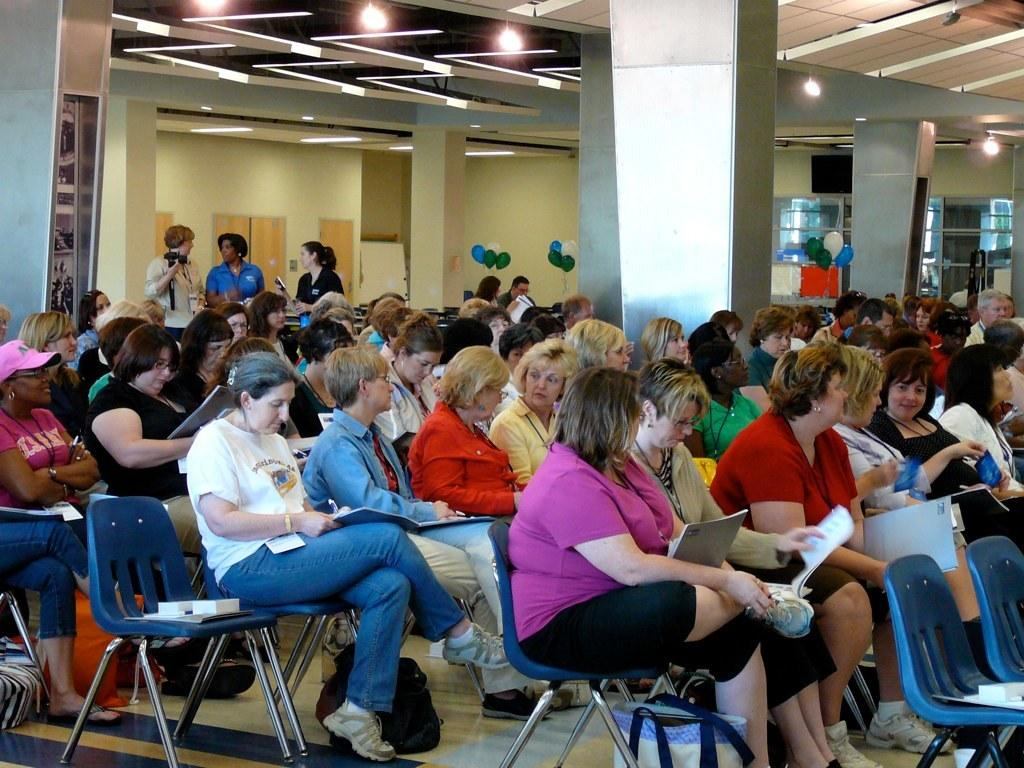What are the people in the image doing? The people in the image are sitting on chairs. Can you describe the people in the background of the image? In the background of the image, there are people standing. What type of crow can be seen perched on the chair in the image? There is no crow present in the image; it features people sitting on chairs and standing in the background. 